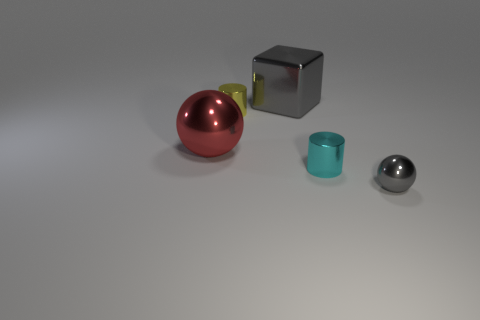What is the shape of the red metallic object?
Make the answer very short. Sphere. Are there any other things that are the same shape as the large gray metal thing?
Your answer should be compact. No. Is the number of big red metal objects that are right of the yellow object less than the number of big blue objects?
Give a very brief answer. No. There is a ball that is on the right side of the large metal block; is it the same color as the big shiny block?
Make the answer very short. Yes. What number of matte things are tiny gray balls or brown cylinders?
Your answer should be very brief. 0. There is a large ball that is made of the same material as the large gray block; what is its color?
Provide a succinct answer. Red. How many blocks are shiny objects or cyan metallic objects?
Offer a very short reply. 1. How many objects are either tiny red metal balls or shiny blocks that are behind the large metallic sphere?
Your answer should be very brief. 1. Are any big cylinders visible?
Your response must be concise. No. How many balls are the same color as the block?
Your answer should be compact. 1. 